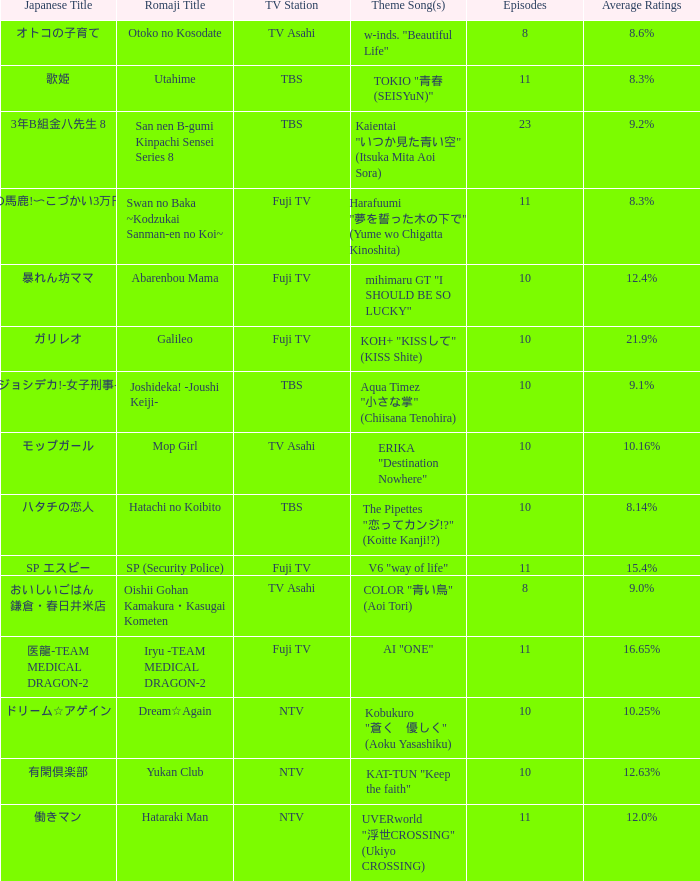What Episode has a Theme Song of koh+ "kissして" (kiss shite)? 10.0. 